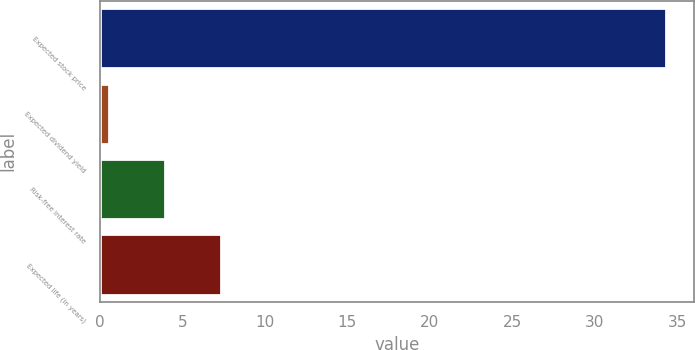Convert chart to OTSL. <chart><loc_0><loc_0><loc_500><loc_500><bar_chart><fcel>Expected stock price<fcel>Expected dividend yield<fcel>Risk-free interest rate<fcel>Expected life (in years)<nl><fcel>34.3<fcel>0.59<fcel>3.96<fcel>7.33<nl></chart> 